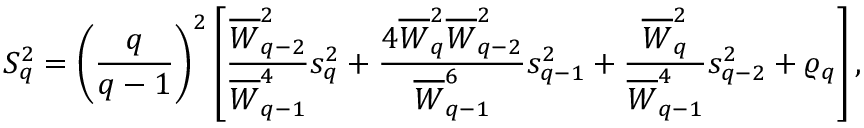<formula> <loc_0><loc_0><loc_500><loc_500>S _ { q } ^ { 2 } = \left ( \frac { q } { q - 1 } \right ) ^ { 2 } \left [ \frac { { \overline { W } } _ { q - 2 } ^ { 2 } } { { \overline { W } } _ { q - 1 } ^ { 4 } } s _ { q } ^ { 2 } + \frac { 4 { \overline { W } } _ { q } ^ { 2 } { \overline { W } } _ { q - 2 } ^ { 2 } } { { \overline { W } } _ { q - 1 } ^ { 6 } } s _ { q - 1 } ^ { 2 } + \frac { { \overline { W } } _ { q } ^ { 2 } } { { \overline { W } } _ { q - 1 } ^ { 4 } } s _ { q - 2 } ^ { 2 } + \varrho _ { q } \right ] ,</formula> 